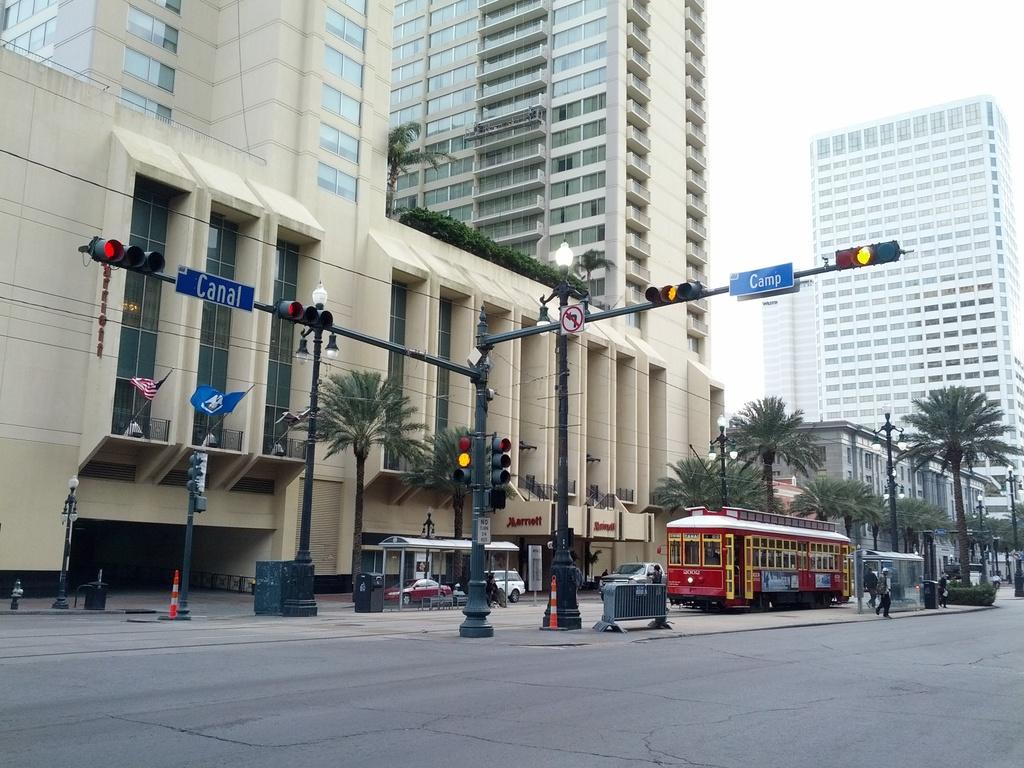Is there a marriott nearby?
Give a very brief answer. Yes. 